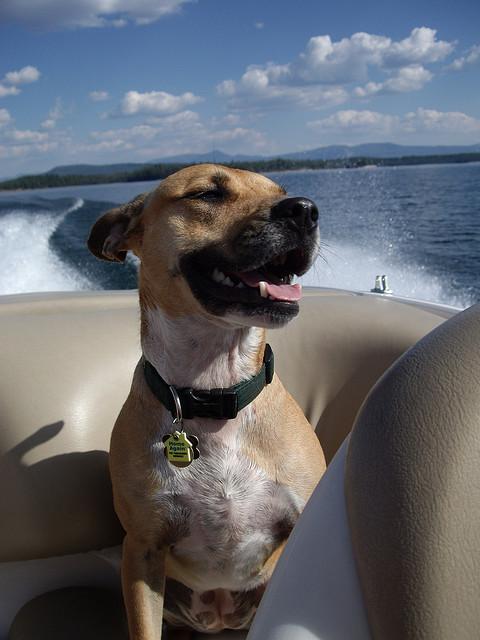Does this animal have a license?
Keep it brief. Yes. What is the dog riding in?
Quick response, please. Boat. What is the dog looking at?
Keep it brief. Water. Are there waves?
Give a very brief answer. Yes. 